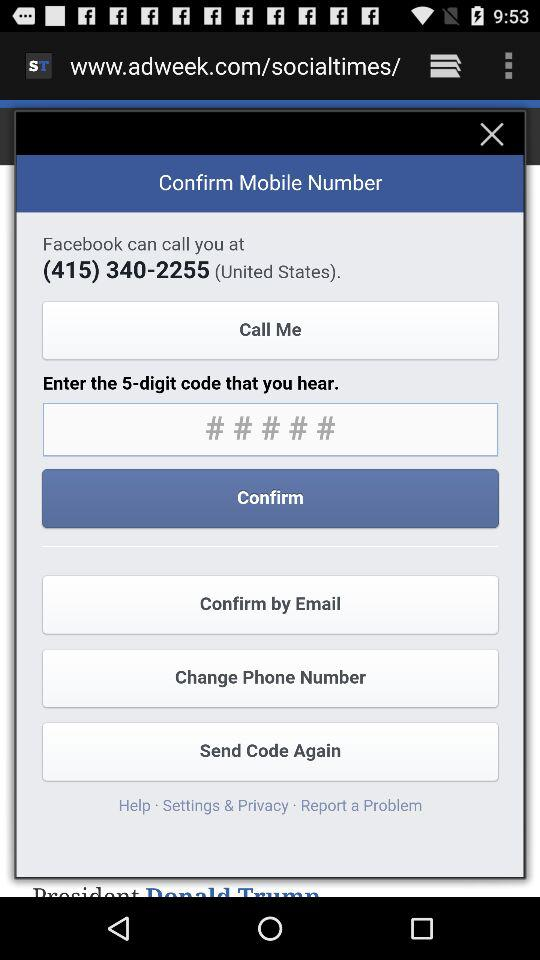How many digits does the code have? The code has 5 digits. 